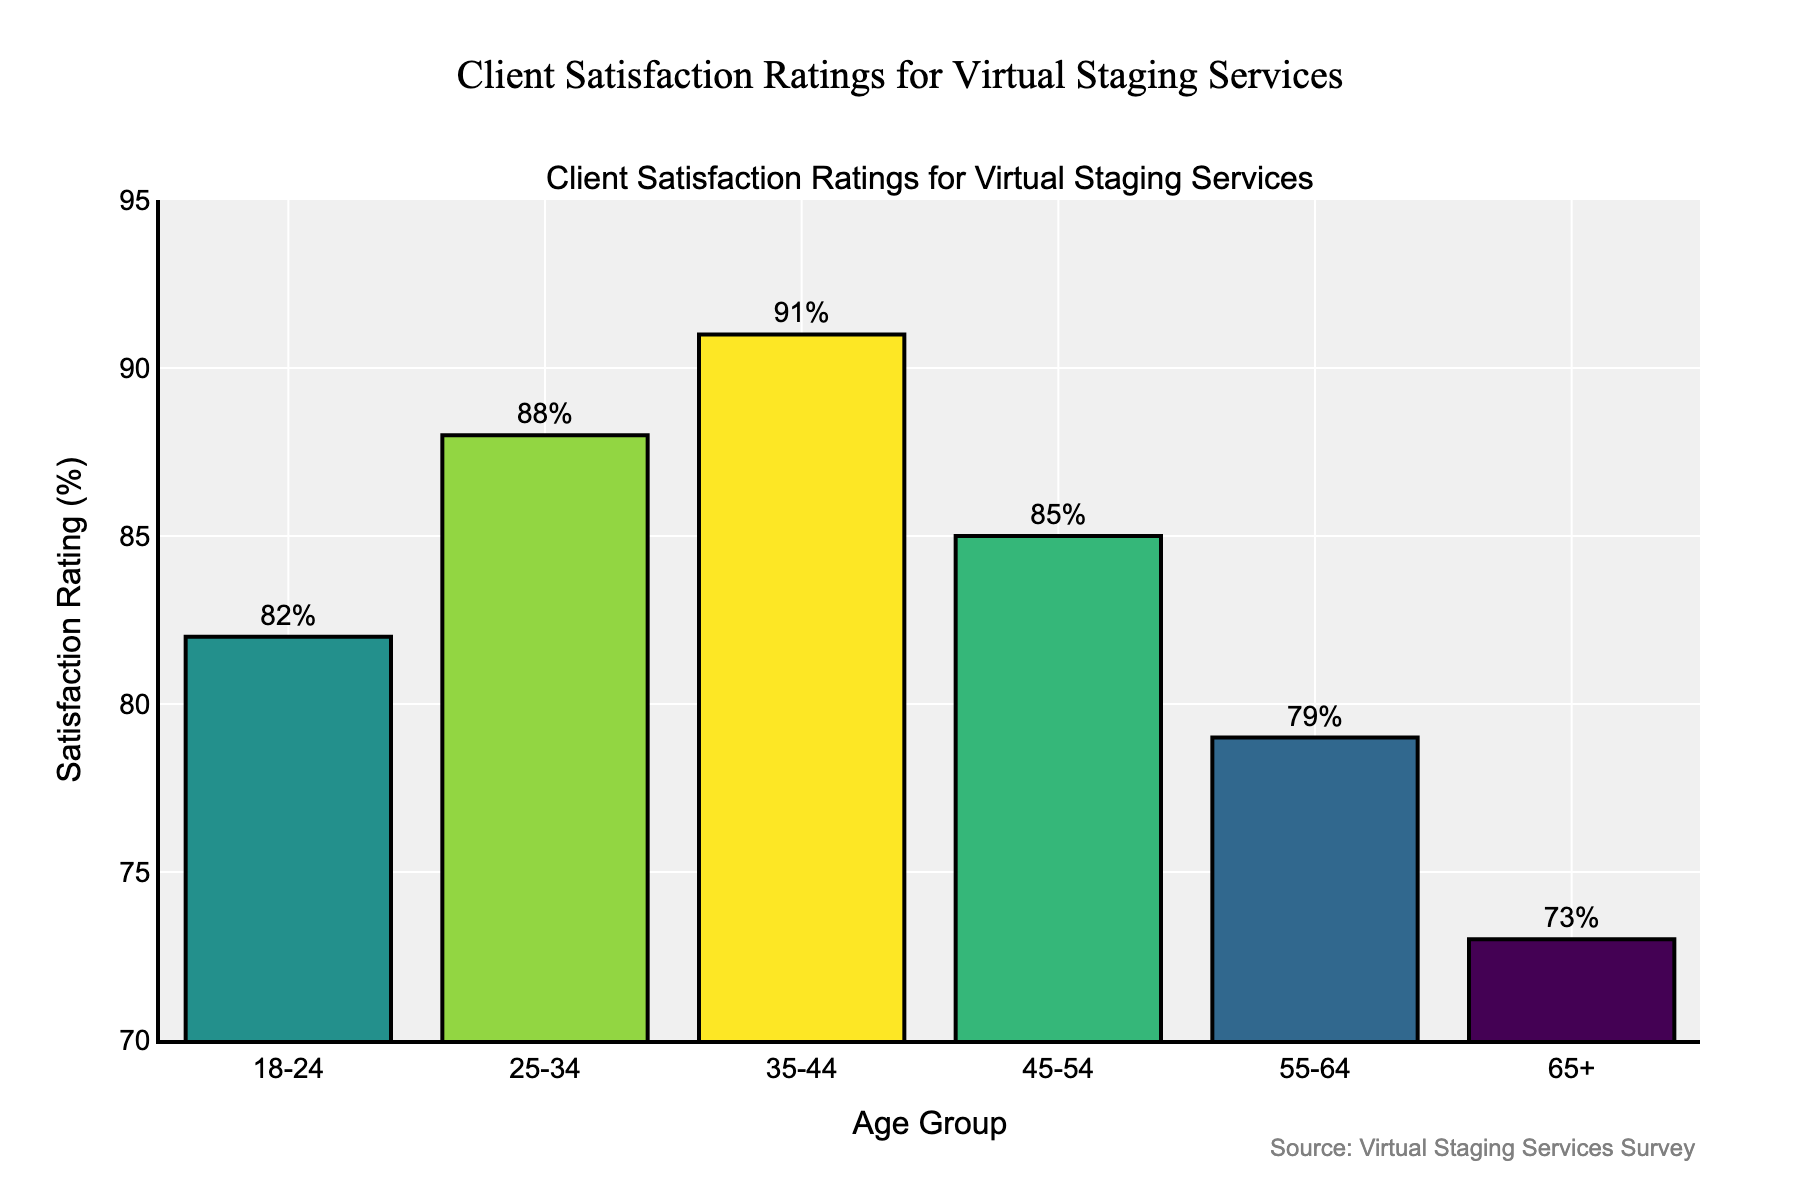Which age group has the highest satisfaction rating? The bar chart shows satisfaction ratings for different age groups. By comparing the heights of the bars, the age group 35-44 has the highest satisfaction rating at 91%.
Answer: 35-44 Which age group has the lowest satisfaction rating? By comparing the heights of the bars, the age group 65+ has the lowest satisfaction rating at 73%.
Answer: 65+ What is the difference in satisfaction ratings between the age groups 35-44 and 65+? The satisfaction rating for 35-44 is 91%, and for 65+ it is 73%. The difference is calculated as 91 - 73 = 18%.
Answer: 18% What is the average satisfaction rating across all age groups? Sum of the ratings is 82 + 88 + 91 + 85 + 79 + 73 = 498. There are 6 age groups, so the average rating is 498 / 6 = 83%.
Answer: 83% Which two age groups have satisfaction ratings closest to each other? The satisfaction ratings for the age groups are 82, 88, 91, 85, 79, and 73. The closest ratings are for the age groups 18-24 (82%) and 55-64 (79%), with a difference of 3%.
Answer: 18-24 and 55-64 Is the satisfaction rating for the age group 25-34 higher or lower than the overall average satisfaction rating? The overall average satisfaction rating is 83%. The rating for the age group 25-34 is 88%, which is higher than the average.
Answer: higher What is the combined total satisfaction rating for the age groups 18-24 and 45-54? The satisfaction ratings for 18-24 and 45-54 are 82% and 85%, respectively. The combined total is 82 + 85 = 167%.
Answer: 167% For which age group is the satisfaction rating closest to 80%? The satisfaction ratings closest to 80% are for the age groups 18-24 (82%) and 55-64 (79%). Comparing their differences from 80%, we see 18-24 is 2% away and 55-64 is 1% away. So, 55-64 is the closest.
Answer: 55-64 How many age groups have a satisfaction rating greater than 80%? The age groups with satisfaction ratings greater than 80% are 18-24 (82%), 25-34 (88%), 35-44 (91%), and 45-54 (85%). That makes a total of 4 age groups.
Answer: 4 